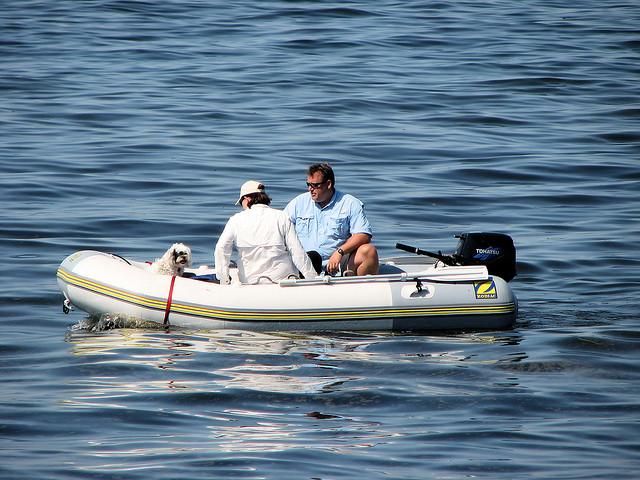What kind of boat is the man in?
Be succinct. Raft. Is the dog having fun?
Answer briefly. Yes. Who is wearing the white hat?
Quick response, please. Lady. What color is the boat?
Quick response, please. White. How many people are in the boat?
Give a very brief answer. 2. Could this be in Asia?
Short answer required. No. Is this boat a pontoon?
Answer briefly. No. 